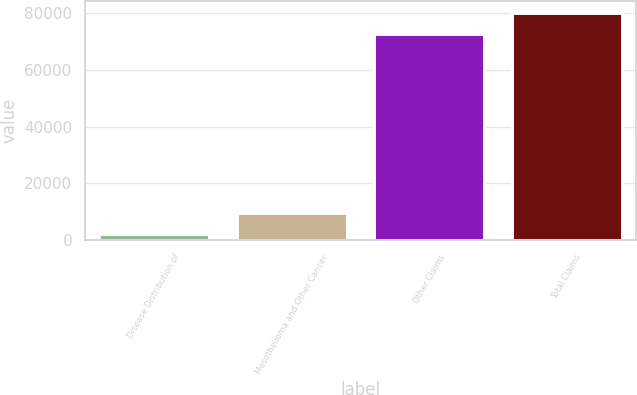Convert chart. <chart><loc_0><loc_0><loc_500><loc_500><bar_chart><fcel>Disease Distribution of<fcel>Mesothelioma and Other Cancer<fcel>Other Claims<fcel>Total Claims<nl><fcel>2004<fcel>9438.4<fcel>72814<fcel>80248.4<nl></chart> 